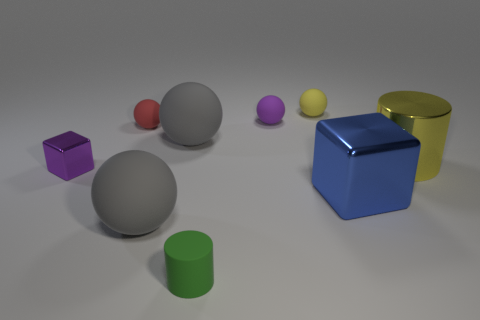There is a small object that is both in front of the red ball and behind the green matte cylinder; what is its material?
Your answer should be compact. Metal. There is a big gray thing in front of the small metal block; what shape is it?
Ensure brevity in your answer.  Sphere. The small purple object that is left of the big gray rubber ball in front of the big cylinder is what shape?
Make the answer very short. Cube. Is there another large blue object that has the same shape as the big blue metal object?
Your answer should be very brief. No. What is the shape of the yellow rubber object that is the same size as the red sphere?
Your response must be concise. Sphere. There is a large thing that is behind the cylinder that is behind the blue metal thing; is there a thing in front of it?
Provide a short and direct response. Yes. Is there a yellow object of the same size as the red matte ball?
Offer a terse response. Yes. How big is the shiny block that is to the right of the small green cylinder?
Offer a very short reply. Large. There is a cylinder that is right of the cylinder on the left side of the rubber object behind the purple sphere; what color is it?
Your answer should be compact. Yellow. What color is the metallic block that is behind the blue block in front of the yellow shiny cylinder?
Give a very brief answer. Purple. 